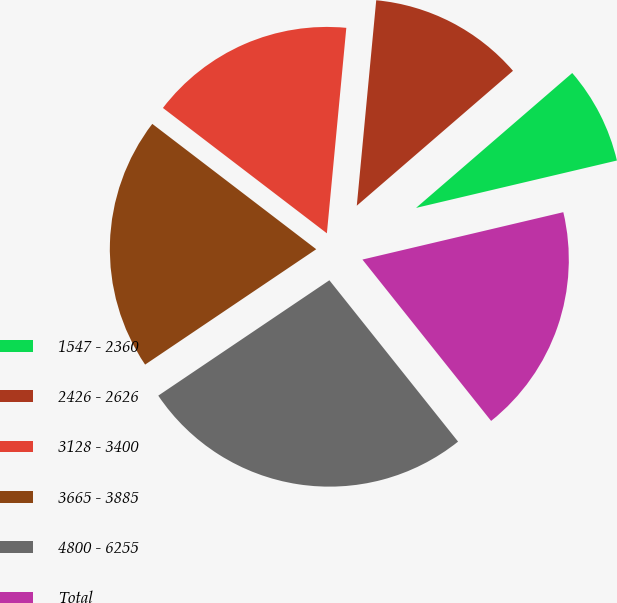Convert chart. <chart><loc_0><loc_0><loc_500><loc_500><pie_chart><fcel>1547 - 2360<fcel>2426 - 2626<fcel>3128 - 3400<fcel>3665 - 3885<fcel>4800 - 6255<fcel>Total<nl><fcel>7.65%<fcel>12.16%<fcel>16.11%<fcel>19.83%<fcel>26.27%<fcel>17.97%<nl></chart> 